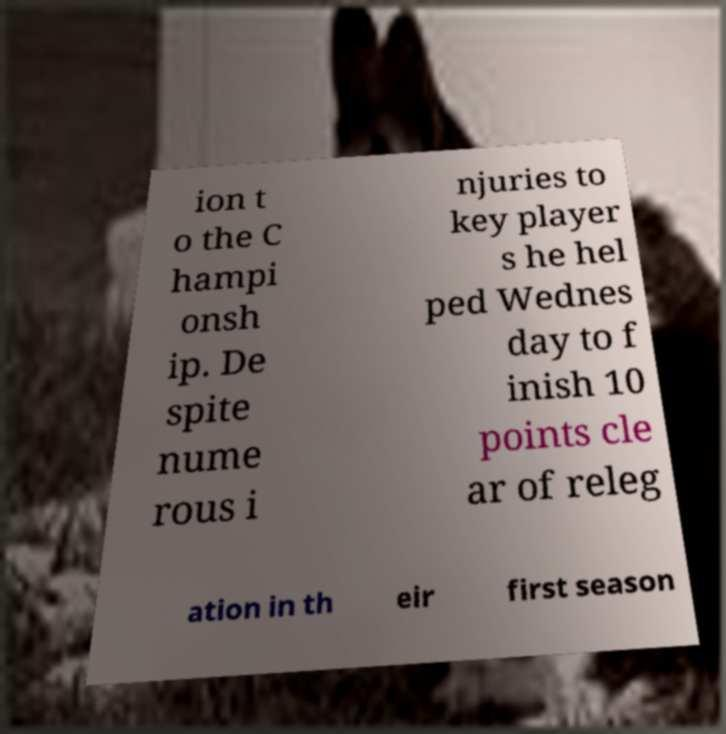I need the written content from this picture converted into text. Can you do that? ion t o the C hampi onsh ip. De spite nume rous i njuries to key player s he hel ped Wednes day to f inish 10 points cle ar of releg ation in th eir first season 